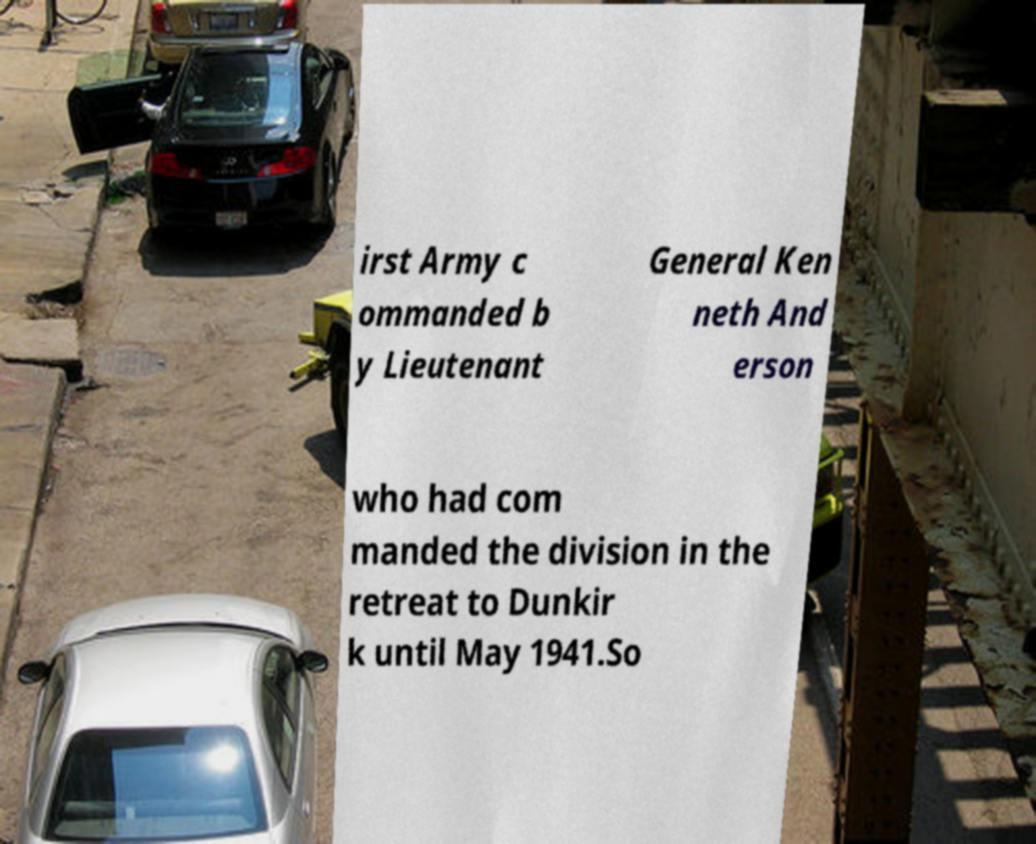Can you read and provide the text displayed in the image?This photo seems to have some interesting text. Can you extract and type it out for me? irst Army c ommanded b y Lieutenant General Ken neth And erson who had com manded the division in the retreat to Dunkir k until May 1941.So 